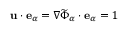<formula> <loc_0><loc_0><loc_500><loc_500>u \cdot e _ { \alpha } = \nabla \widetilde { \Phi } _ { \alpha } \cdot e _ { \alpha } = 1</formula> 